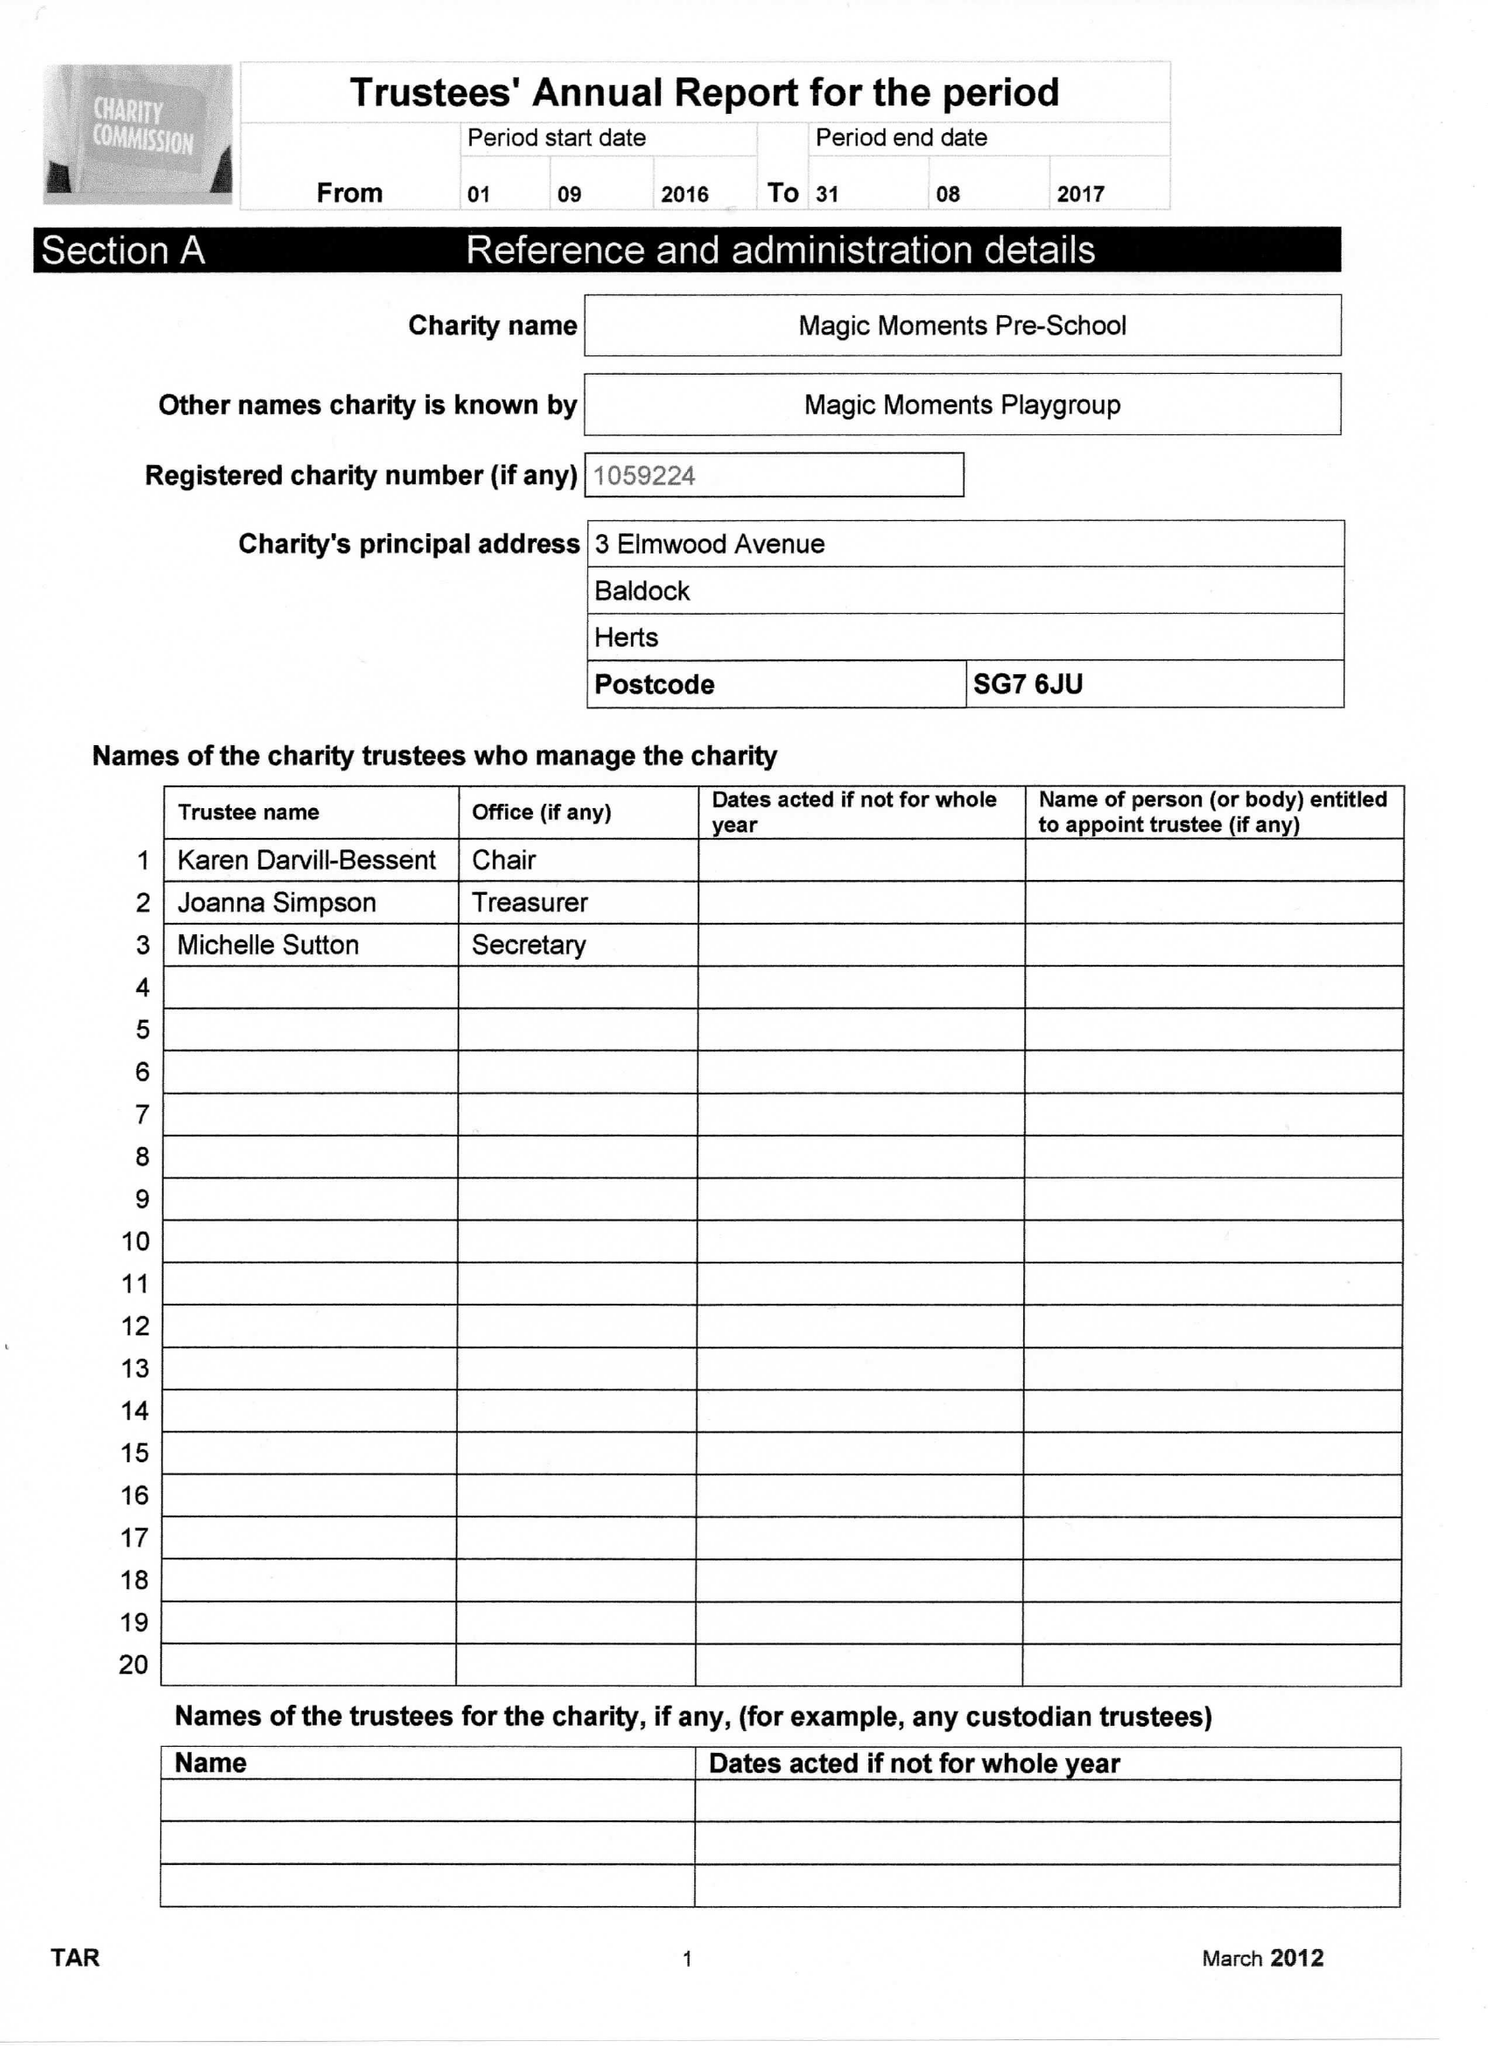What is the value for the spending_annually_in_british_pounds?
Answer the question using a single word or phrase. 127257.00 